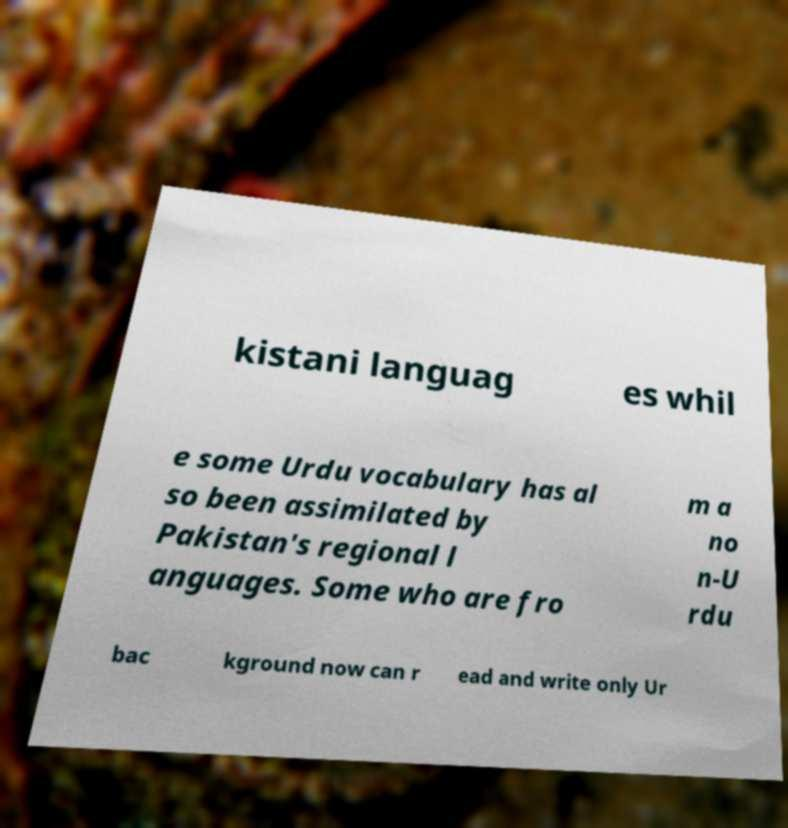Please identify and transcribe the text found in this image. kistani languag es whil e some Urdu vocabulary has al so been assimilated by Pakistan's regional l anguages. Some who are fro m a no n-U rdu bac kground now can r ead and write only Ur 